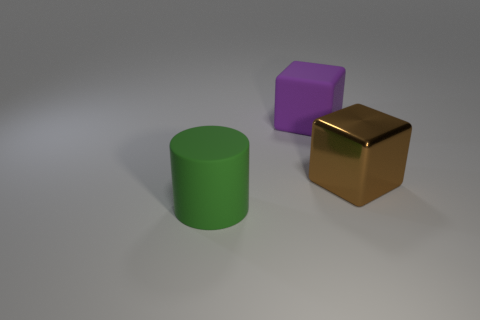What is the material of the big object that is both on the left side of the large brown cube and in front of the big purple rubber block? Based on the image, the material of the big object, which is a green cylinder, cannot be determined with certainty. While the given answer was 'rubber', without additional context, we can't confirm the actual material solely from the visual information. It may be a digital rendering, which could represent a variety of materials, including but not limited to rubber. 